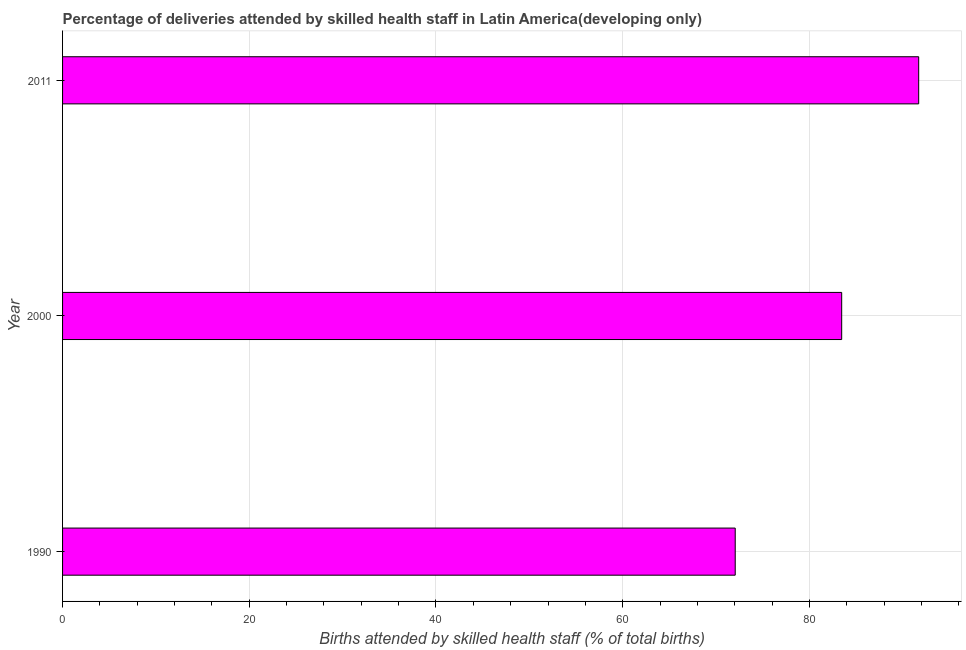Does the graph contain any zero values?
Offer a terse response. No. What is the title of the graph?
Your response must be concise. Percentage of deliveries attended by skilled health staff in Latin America(developing only). What is the label or title of the X-axis?
Provide a succinct answer. Births attended by skilled health staff (% of total births). What is the number of births attended by skilled health staff in 2000?
Offer a terse response. 83.46. Across all years, what is the maximum number of births attended by skilled health staff?
Provide a succinct answer. 91.71. Across all years, what is the minimum number of births attended by skilled health staff?
Give a very brief answer. 72.05. What is the sum of the number of births attended by skilled health staff?
Provide a succinct answer. 247.22. What is the difference between the number of births attended by skilled health staff in 1990 and 2011?
Your answer should be very brief. -19.65. What is the average number of births attended by skilled health staff per year?
Your answer should be compact. 82.41. What is the median number of births attended by skilled health staff?
Offer a very short reply. 83.46. In how many years, is the number of births attended by skilled health staff greater than 12 %?
Offer a very short reply. 3. Do a majority of the years between 1990 and 2000 (inclusive) have number of births attended by skilled health staff greater than 24 %?
Provide a succinct answer. Yes. What is the ratio of the number of births attended by skilled health staff in 1990 to that in 2011?
Make the answer very short. 0.79. Is the number of births attended by skilled health staff in 2000 less than that in 2011?
Your answer should be very brief. Yes. What is the difference between the highest and the second highest number of births attended by skilled health staff?
Offer a terse response. 8.25. What is the difference between the highest and the lowest number of births attended by skilled health staff?
Keep it short and to the point. 19.65. In how many years, is the number of births attended by skilled health staff greater than the average number of births attended by skilled health staff taken over all years?
Ensure brevity in your answer.  2. How many bars are there?
Provide a short and direct response. 3. Are all the bars in the graph horizontal?
Your answer should be compact. Yes. How many years are there in the graph?
Offer a very short reply. 3. What is the difference between two consecutive major ticks on the X-axis?
Make the answer very short. 20. What is the Births attended by skilled health staff (% of total births) in 1990?
Your answer should be very brief. 72.05. What is the Births attended by skilled health staff (% of total births) in 2000?
Your answer should be very brief. 83.46. What is the Births attended by skilled health staff (% of total births) of 2011?
Your answer should be very brief. 91.71. What is the difference between the Births attended by skilled health staff (% of total births) in 1990 and 2000?
Your answer should be very brief. -11.41. What is the difference between the Births attended by skilled health staff (% of total births) in 1990 and 2011?
Provide a succinct answer. -19.65. What is the difference between the Births attended by skilled health staff (% of total births) in 2000 and 2011?
Give a very brief answer. -8.25. What is the ratio of the Births attended by skilled health staff (% of total births) in 1990 to that in 2000?
Keep it short and to the point. 0.86. What is the ratio of the Births attended by skilled health staff (% of total births) in 1990 to that in 2011?
Give a very brief answer. 0.79. What is the ratio of the Births attended by skilled health staff (% of total births) in 2000 to that in 2011?
Your response must be concise. 0.91. 